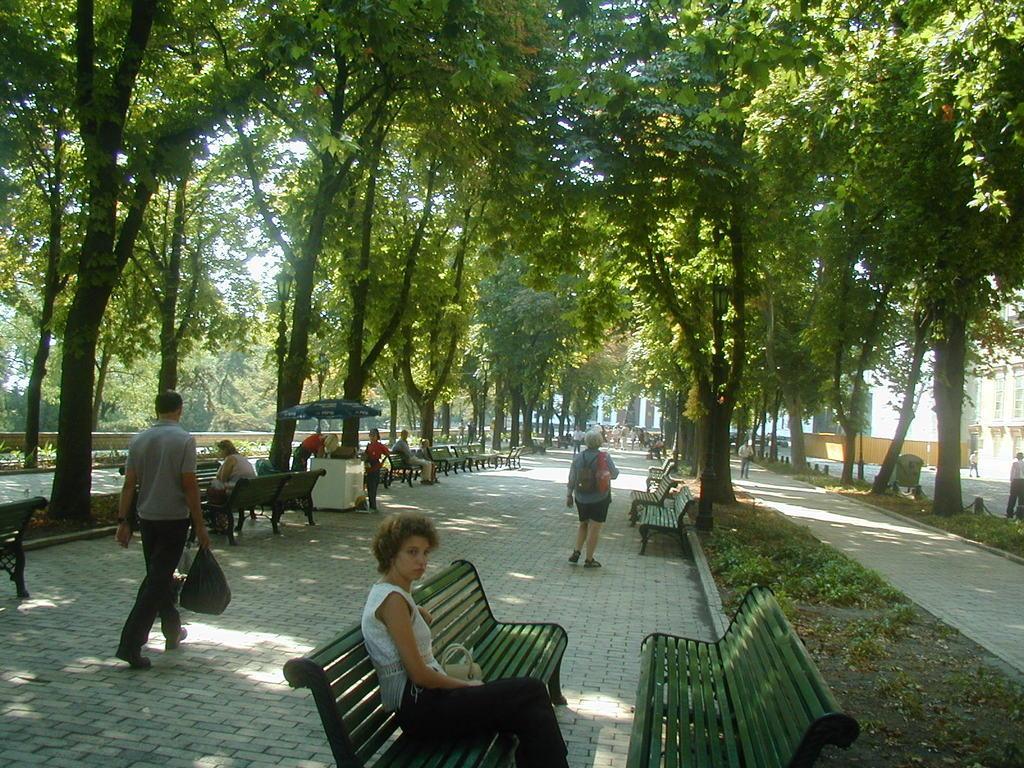In one or two sentences, can you explain what this image depicts? Few persons are standing and few persons are sitting on the benches,this person walking and holding cover. On the background we can see trees,building,benches. plants. 